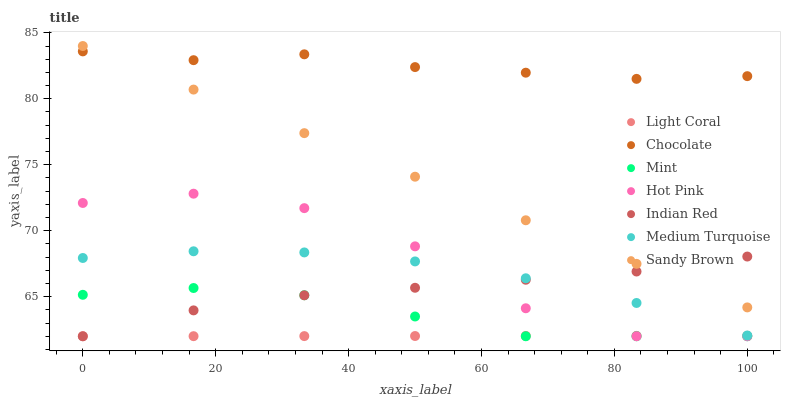Does Light Coral have the minimum area under the curve?
Answer yes or no. Yes. Does Chocolate have the maximum area under the curve?
Answer yes or no. Yes. Does Sandy Brown have the minimum area under the curve?
Answer yes or no. No. Does Sandy Brown have the maximum area under the curve?
Answer yes or no. No. Is Sandy Brown the smoothest?
Answer yes or no. Yes. Is Hot Pink the roughest?
Answer yes or no. Yes. Is Hot Pink the smoothest?
Answer yes or no. No. Is Sandy Brown the roughest?
Answer yes or no. No. Does Indian Red have the lowest value?
Answer yes or no. Yes. Does Sandy Brown have the lowest value?
Answer yes or no. No. Does Sandy Brown have the highest value?
Answer yes or no. Yes. Does Hot Pink have the highest value?
Answer yes or no. No. Is Mint less than Medium Turquoise?
Answer yes or no. Yes. Is Sandy Brown greater than Medium Turquoise?
Answer yes or no. Yes. Does Light Coral intersect Mint?
Answer yes or no. Yes. Is Light Coral less than Mint?
Answer yes or no. No. Is Light Coral greater than Mint?
Answer yes or no. No. Does Mint intersect Medium Turquoise?
Answer yes or no. No. 